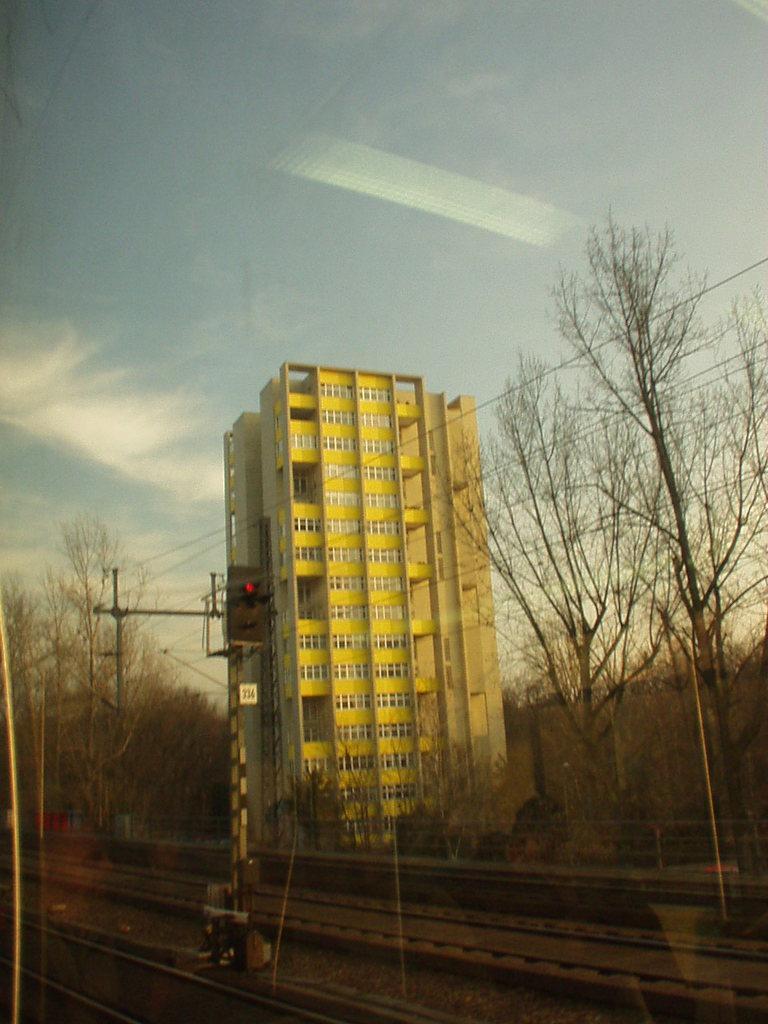How would you summarize this image in a sentence or two? In this image we can see railway tracks, building with windows, trees, signal lights and we can also see the sky. 